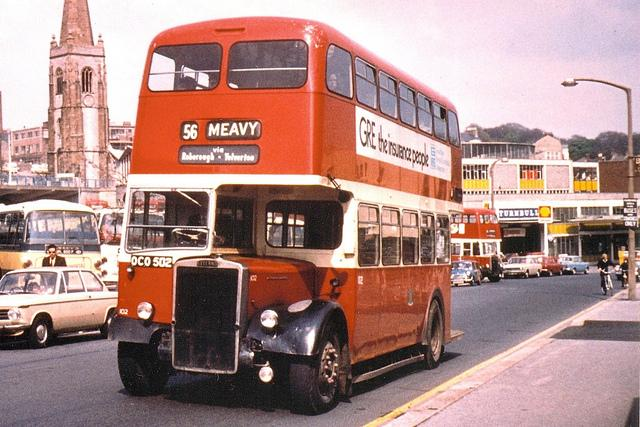Why does the vehicle have two levels?

Choices:
A) for deliveries
B) for speed
C) for sightseeing
D) for decoration for sightseeing 